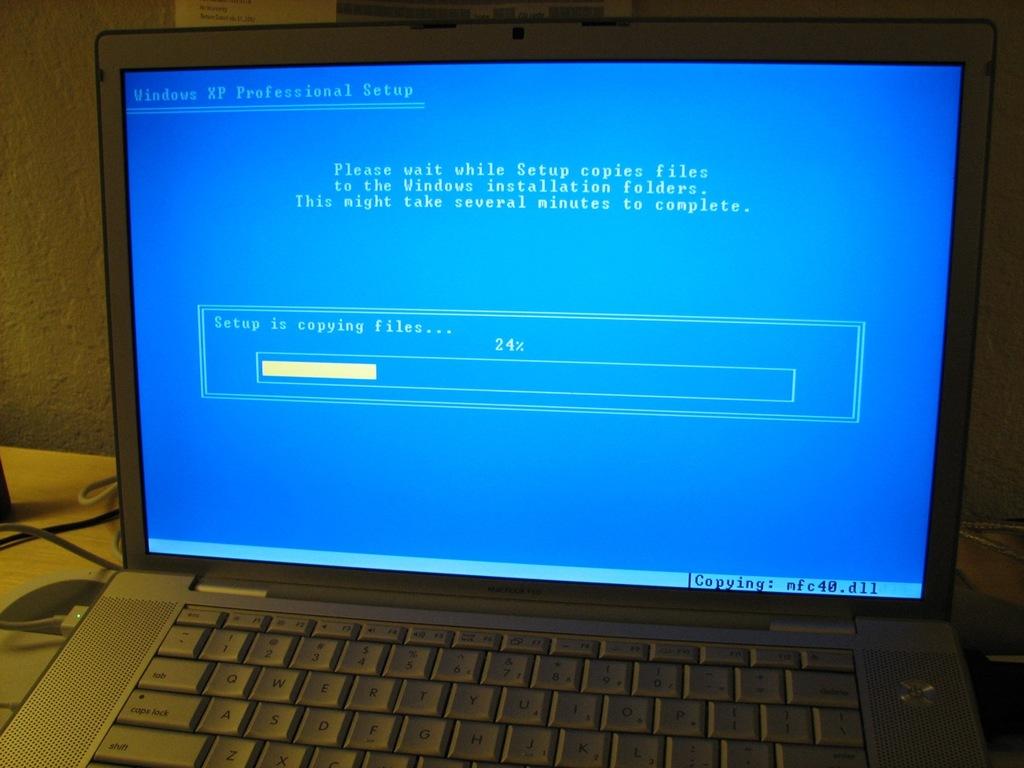What is the percentage of the progress bar at?
Your answer should be very brief. 24%. What version of windows?
Offer a very short reply. Xp professional. 